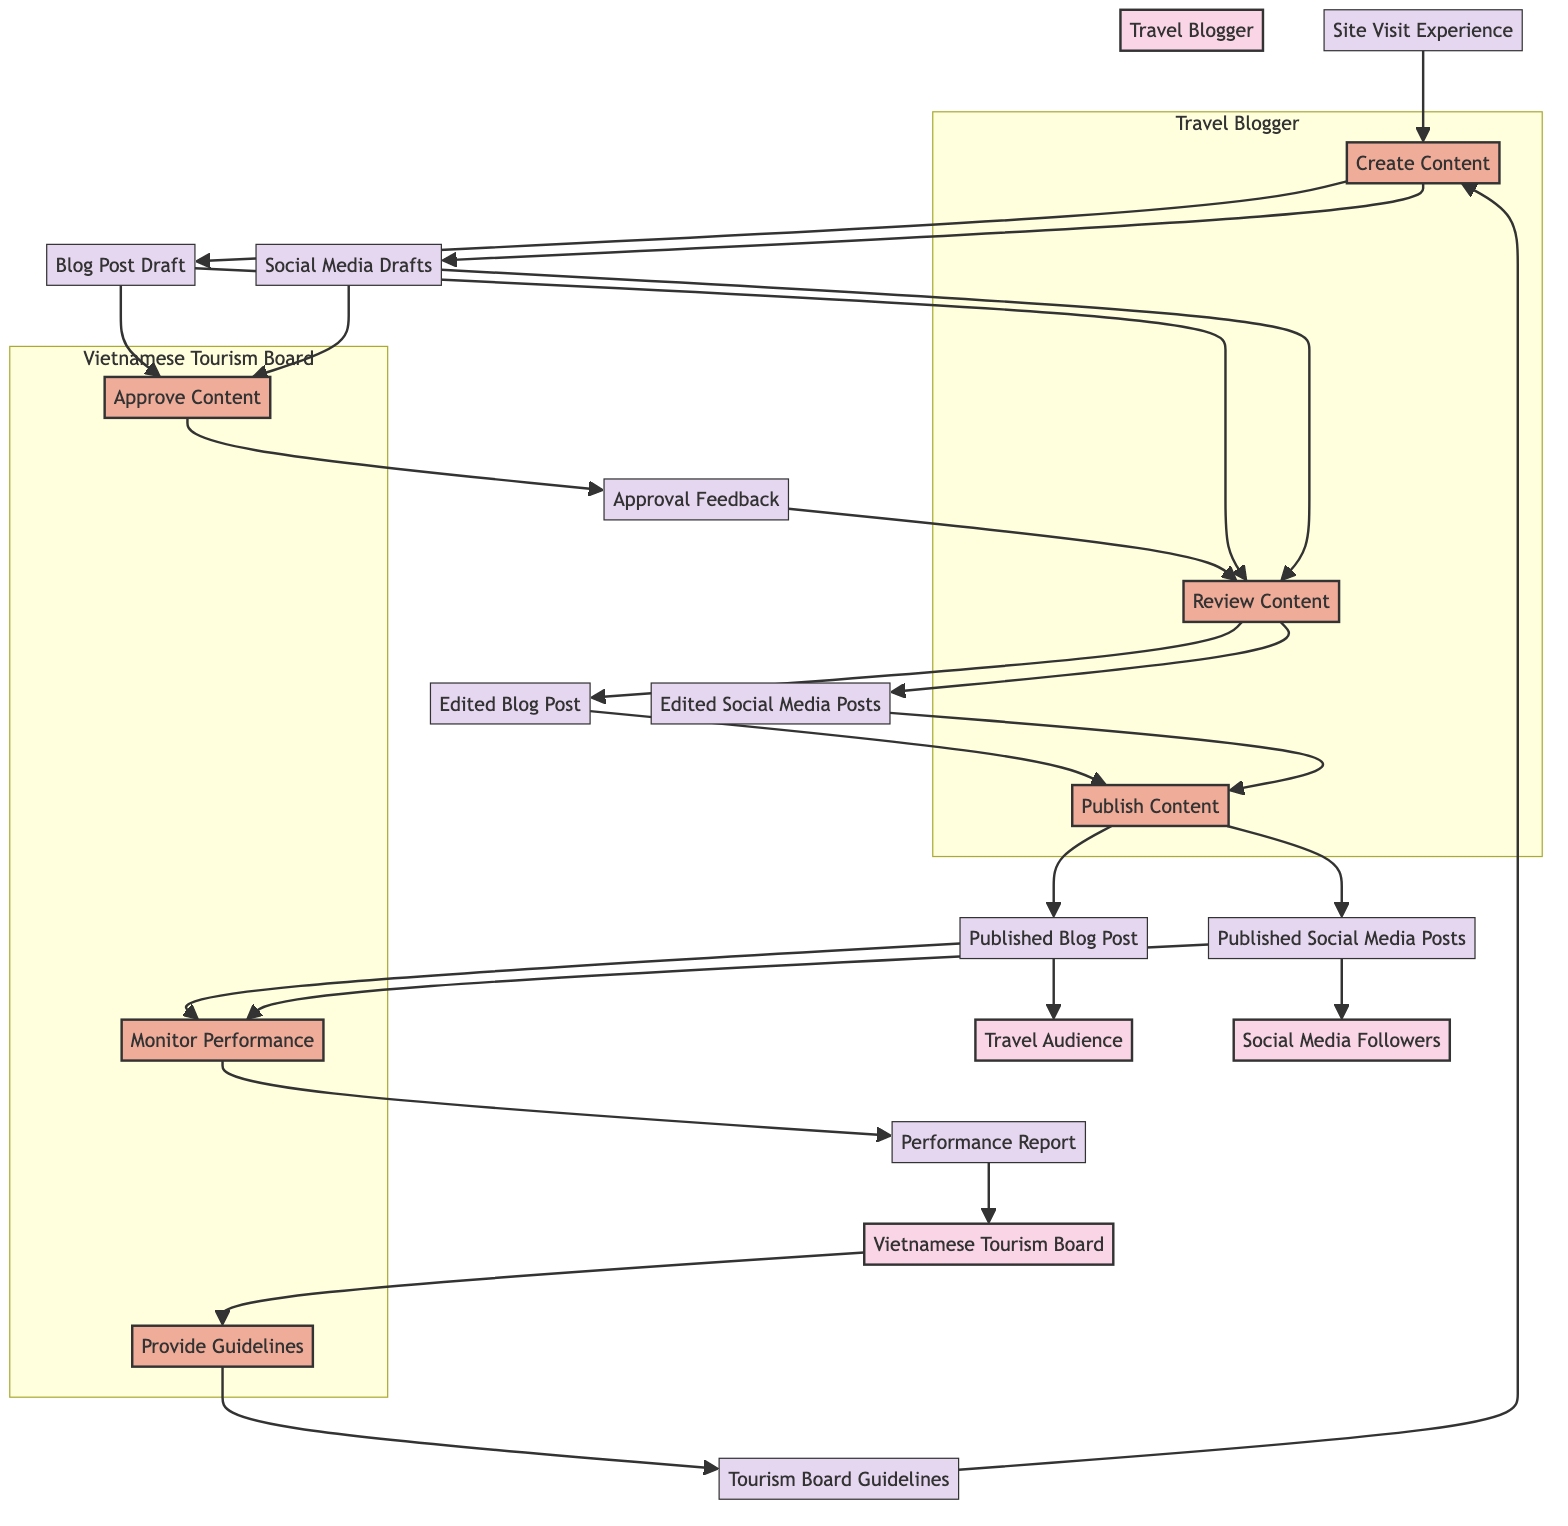What is the input for the Create Content process? According to the diagram, the Create Content process takes two inputs: Tourism Board Guidelines and Site Visit Experience. Both of these are required for the Travel Blogger to create content effectively.
Answer: Tourism Board Guidelines, Site Visit Experience How many processes are performed by the Vietnamese Tourism Board? The Vietnamese Tourism Board has three distinct processes: Provide Guidelines, Approve Content, and Monitor Performance. By counting these processes in the diagram, we can ascertain the total.
Answer: 3 What is the output of the Review Content process? The Review Content process outputs two items: Edited Blog Post and Edited Social Media Posts, which are the revised versions of the original drafts.
Answer: Edited Blog Post, Edited Social Media Posts Which process is responsible for producing the Performance Report? The Monitor Performance process is responsible for producing the Performance Report, which is created after analyzing the outputs from the Publish Content process.
Answer: Monitor Performance What flow leads to the Approval Feedback? The flow leading to Approval Feedback starts with Blog Post Draft and Social Media Drafts being inputs to the Approve Content process, which then produces the Approval Feedback as output.
Answer: Blog Post Draft, Social Media Drafts How many entities are present in the diagram? There are four entities present in the diagram: Vietnamese Tourism Board, Travel Blogger, Travel Audience, and Social Media Followers. By counting them, we can identify the total number of entities in the data flow.
Answer: 4 What is the final output of the Publish Content process? The Publish Content process has two outputs: Published Blog Post and Published Social Media Posts, which are released to the audience and the tourism board after the review.
Answer: Published Blog Post, Published Social Media Posts Which process receives the Tourism Board Guidelines as input? The Create Content process receives the Tourism Board Guidelines as input to guide the content creation process as per the tourism board's standards.
Answer: Create Content 